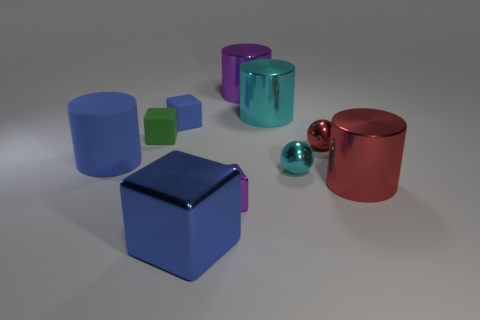Is there a gray cylinder made of the same material as the red cylinder?
Provide a succinct answer. No. What shape is the green thing?
Provide a short and direct response. Cube. What number of cylinders are there?
Give a very brief answer. 4. There is a metal object behind the large cyan metallic cylinder that is left of the cyan metal ball; what color is it?
Your answer should be compact. Purple. What color is the other rubber cube that is the same size as the green matte cube?
Keep it short and to the point. Blue. Are there any other cylinders that have the same color as the rubber cylinder?
Offer a terse response. No. Are any small red shiny spheres visible?
Provide a succinct answer. Yes. There is a purple shiny object in front of the tiny red object; what is its shape?
Offer a terse response. Cube. What number of big things are behind the cyan metal sphere and on the left side of the purple cube?
Give a very brief answer. 1. What number of other things are the same size as the cyan metallic ball?
Your response must be concise. 4. 